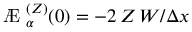<formula> <loc_0><loc_0><loc_500><loc_500>{ \ A E _ { \alpha } ^ { ( Z ) } ( 0 ) = - 2 \, Z \, W / \Delta x }</formula> 